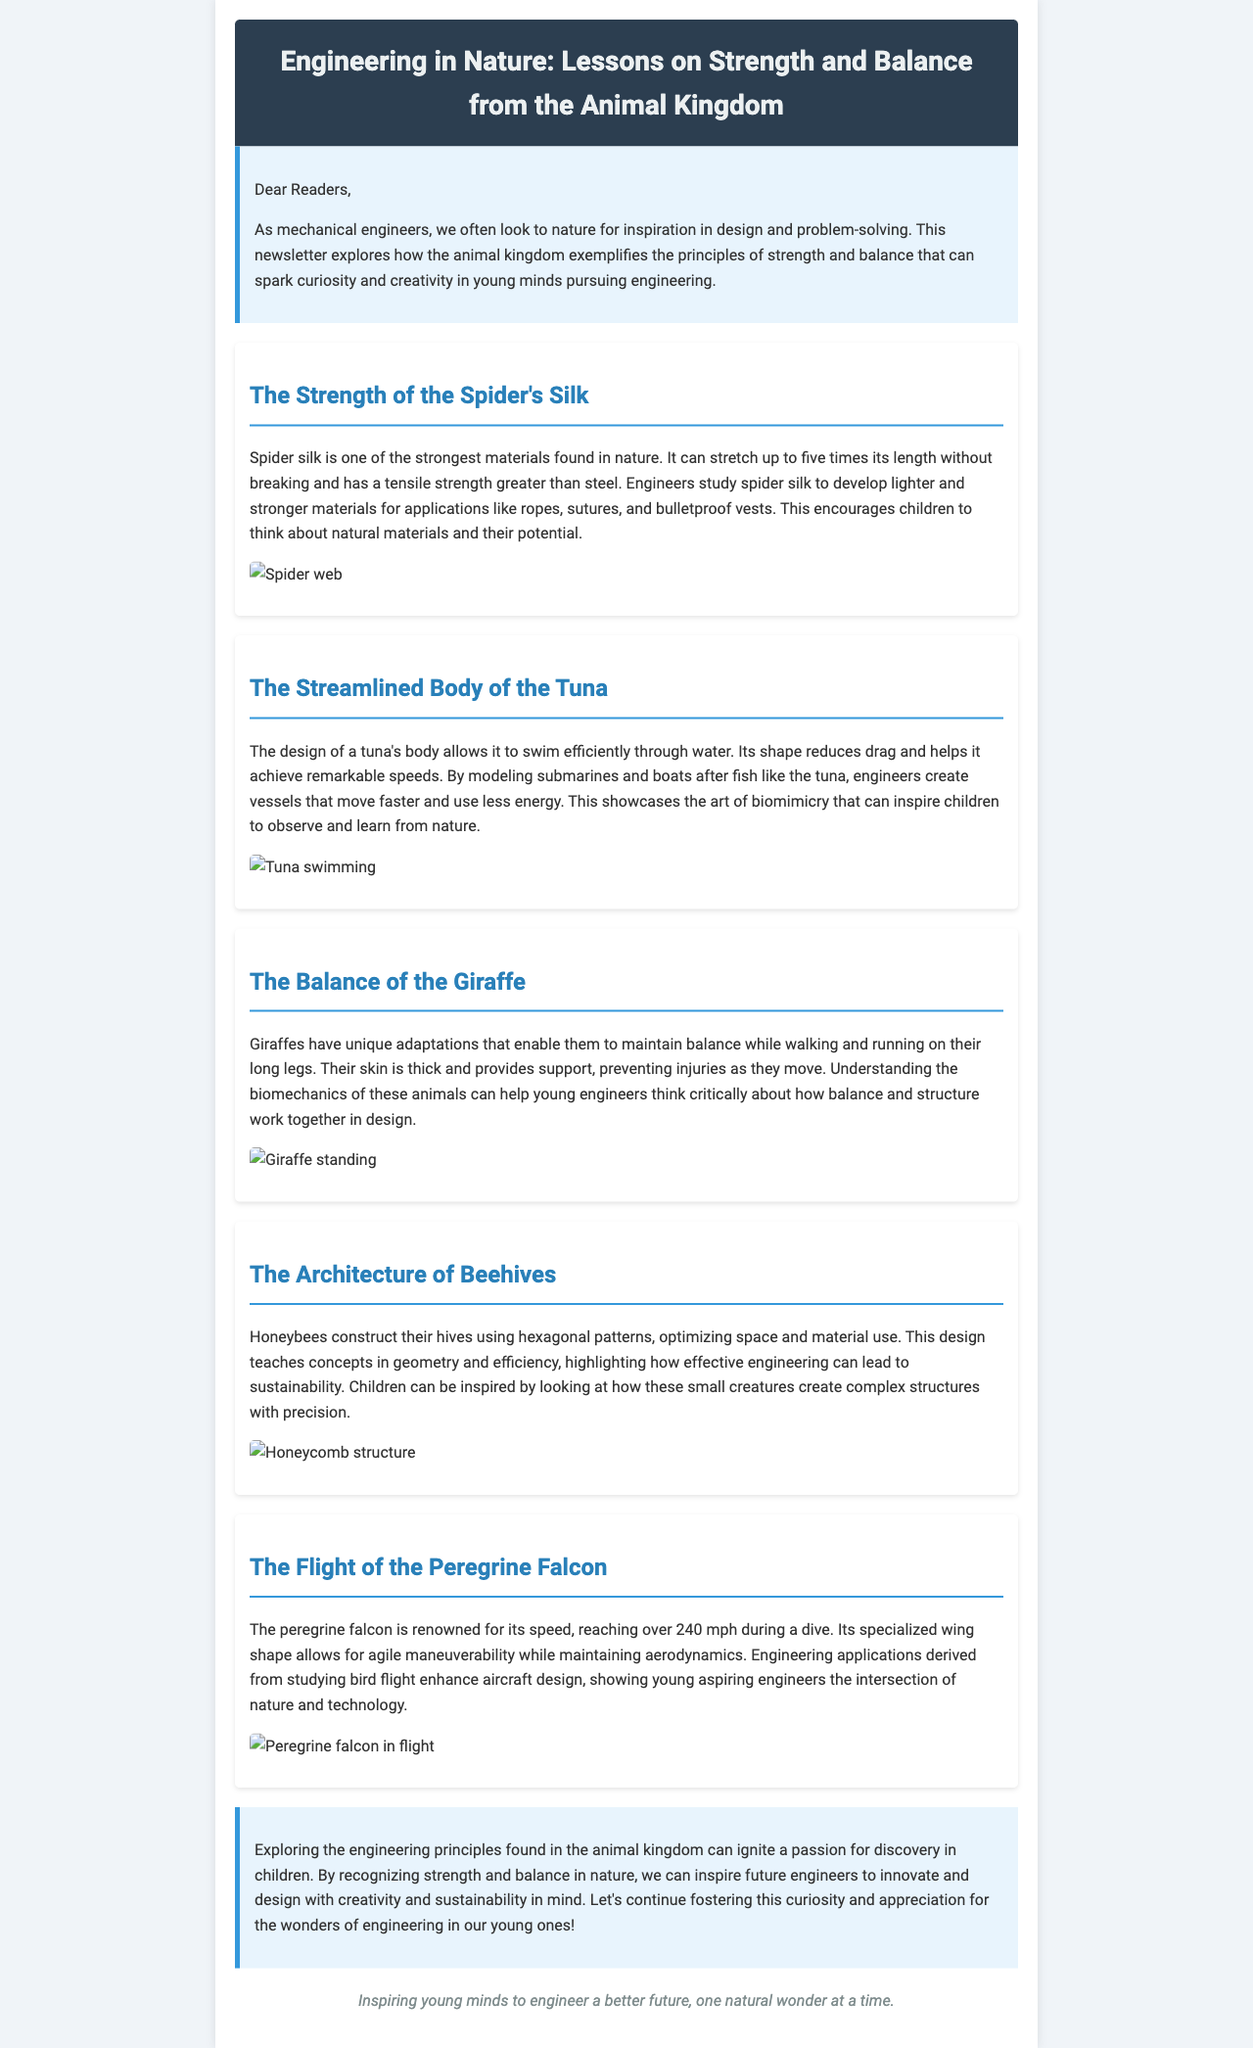What is one of the strongest materials found in nature? The document states that spider silk is one of the strongest materials in nature.
Answer: Spider silk How many times can spider silk stretch without breaking? It can stretch up to five times its length without breaking.
Answer: Five times Which animal's body design helps achieve remarkable swimming speeds? The text mentions the tuna's body design as enabling efficient swimming and speed.
Answer: Tuna What geometrical shape do honeybees use to construct their hives? The document describes that bees use hexagonal patterns in their hive construction.
Answer: Hexagonal What is the maximum speed of a peregrine falcon during a dive? The newsletter informs that the peregrine falcon can reach speeds over 240 mph during a dive.
Answer: 240 mph Which animal is highlighted for its adaptations to maintain balance? The giraffe is noted in the document for its unique adaptations that assist in balance.
Answer: Giraffe What is the primary theme of this newsletter? The newsletter explores engineering lessons derived from nature and animals.
Answer: Engineering in nature What concept does the architecture of beehives teach? The text indicates that it teaches concepts in geometry and efficiency.
Answer: Geometry and efficiency 